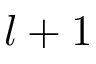<formula> <loc_0><loc_0><loc_500><loc_500>l + 1</formula> 